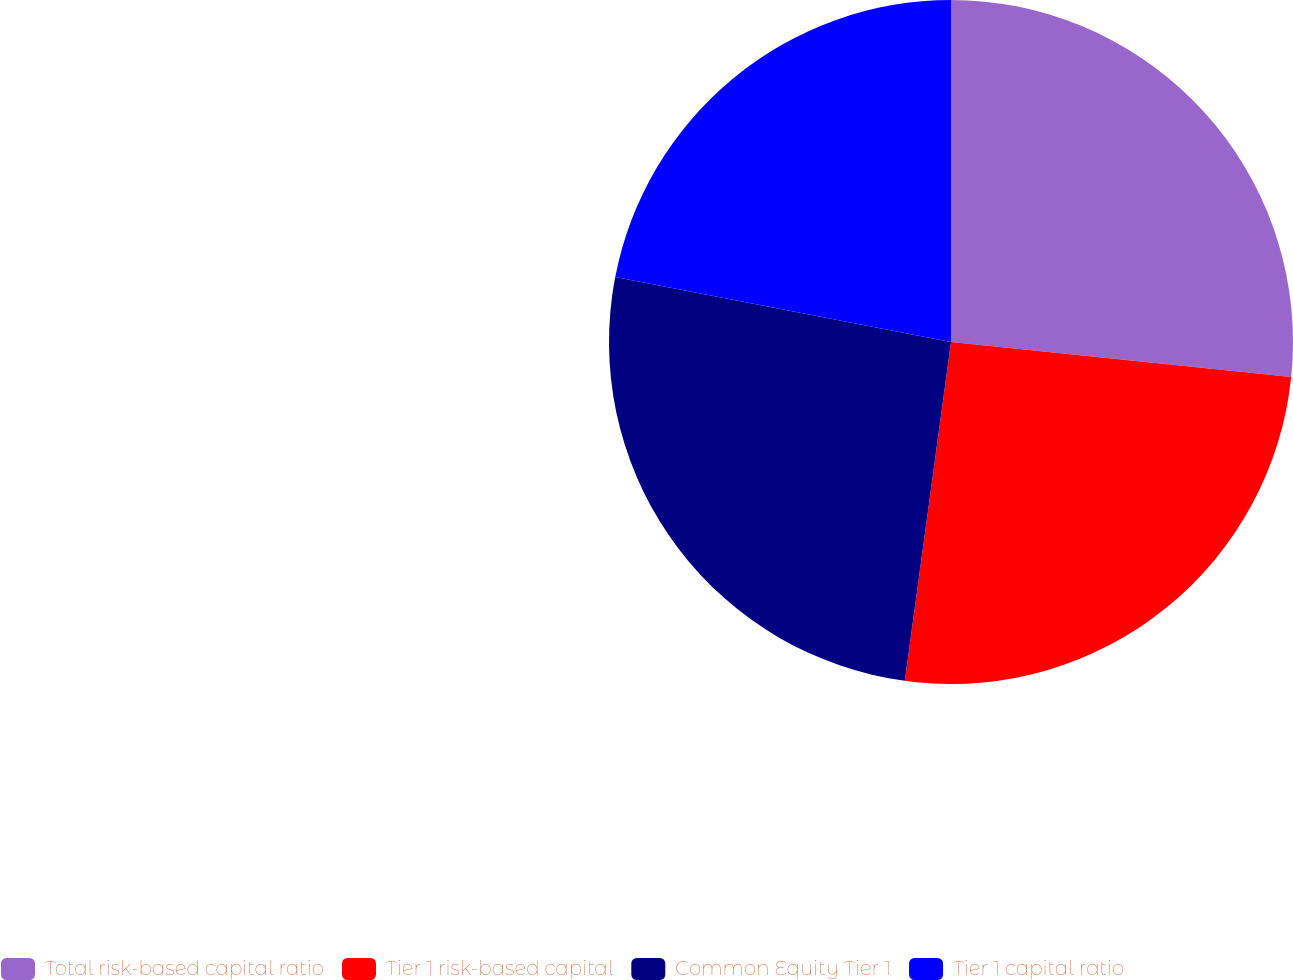Convert chart to OTSL. <chart><loc_0><loc_0><loc_500><loc_500><pie_chart><fcel>Total risk-based capital ratio<fcel>Tier 1 risk-based capital<fcel>Common Equity Tier 1<fcel>Tier 1 capital ratio<nl><fcel>26.63%<fcel>25.52%<fcel>25.89%<fcel>21.95%<nl></chart> 